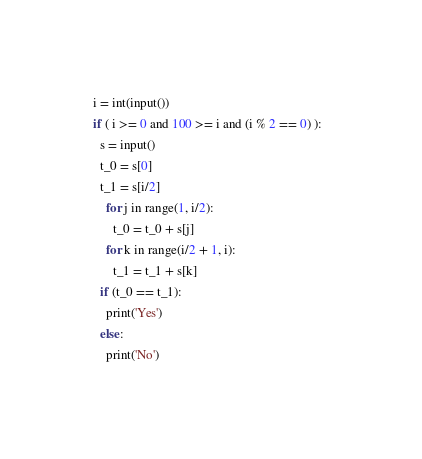Convert code to text. <code><loc_0><loc_0><loc_500><loc_500><_Python_>i = int(input())
if ( i >= 0 and 100 >= i and (i % 2 == 0) ):  
  s = input()
  t_0 = s[0]
  t_1 = s[i/2]
	for j in range(1, i/2):
	  t_0 = t_0 + s[j]
    for k in range(i/2 + 1, i):
      t_1 = t_1 + s[k]
  if (t_0 == t_1):
    print('Yes')
  else:
    print('No')</code> 